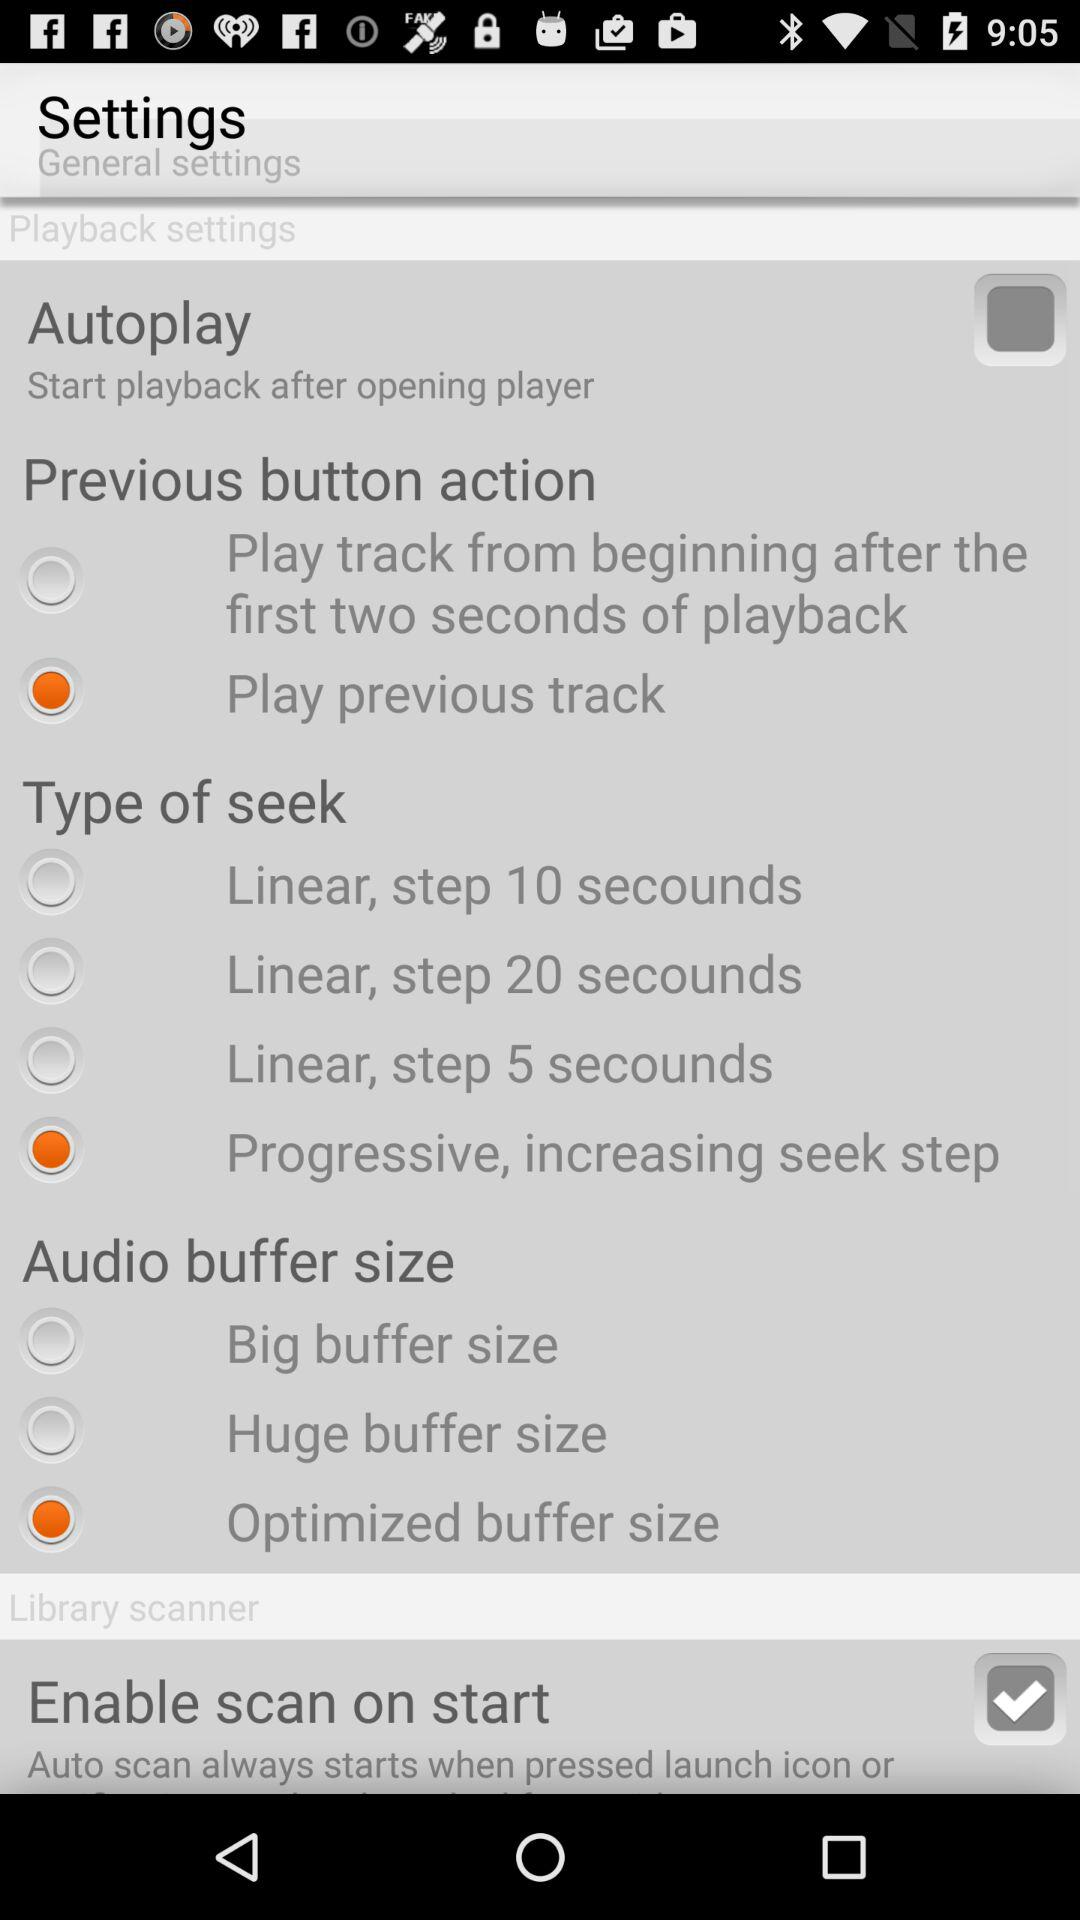Which option is selected in type of seek? The selected option is "Progressive, increasing seek step". 